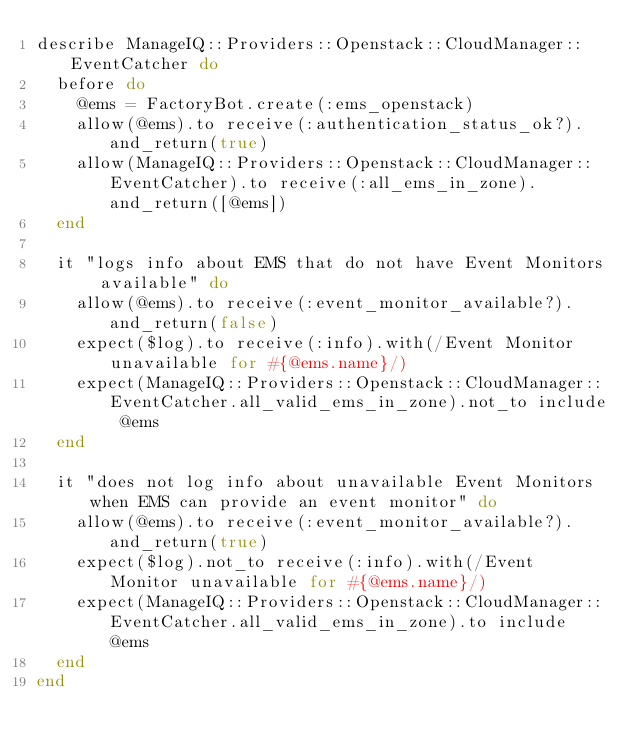<code> <loc_0><loc_0><loc_500><loc_500><_Ruby_>describe ManageIQ::Providers::Openstack::CloudManager::EventCatcher do
  before do
    @ems = FactoryBot.create(:ems_openstack)
    allow(@ems).to receive(:authentication_status_ok?).and_return(true)
    allow(ManageIQ::Providers::Openstack::CloudManager::EventCatcher).to receive(:all_ems_in_zone).and_return([@ems])
  end

  it "logs info about EMS that do not have Event Monitors available" do
    allow(@ems).to receive(:event_monitor_available?).and_return(false)
    expect($log).to receive(:info).with(/Event Monitor unavailable for #{@ems.name}/)
    expect(ManageIQ::Providers::Openstack::CloudManager::EventCatcher.all_valid_ems_in_zone).not_to include @ems
  end

  it "does not log info about unavailable Event Monitors when EMS can provide an event monitor" do
    allow(@ems).to receive(:event_monitor_available?).and_return(true)
    expect($log).not_to receive(:info).with(/Event Monitor unavailable for #{@ems.name}/)
    expect(ManageIQ::Providers::Openstack::CloudManager::EventCatcher.all_valid_ems_in_zone).to include @ems
  end
end
</code> 